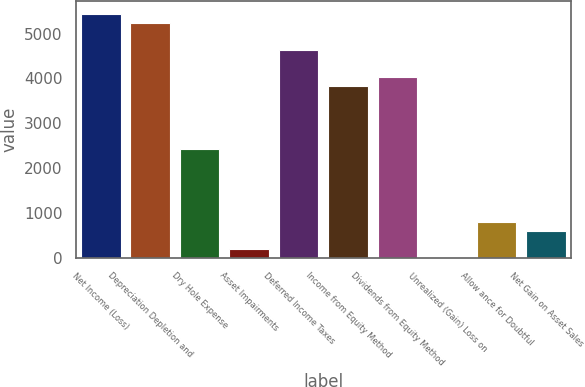Convert chart. <chart><loc_0><loc_0><loc_500><loc_500><bar_chart><fcel>Net Income (Loss)<fcel>Depreciation Depletion and<fcel>Dry Hole Expense<fcel>Asset Impairments<fcel>Deferred Income Taxes<fcel>Income from Equity Method<fcel>Dividends from Equity Method<fcel>Unrealized (Gain) Loss on<fcel>Allow ance for Doubtful<fcel>Net Gain on Asset Sales<nl><fcel>5442.5<fcel>5241<fcel>2420<fcel>203.5<fcel>4636.5<fcel>3830.5<fcel>4032<fcel>2<fcel>808<fcel>606.5<nl></chart> 